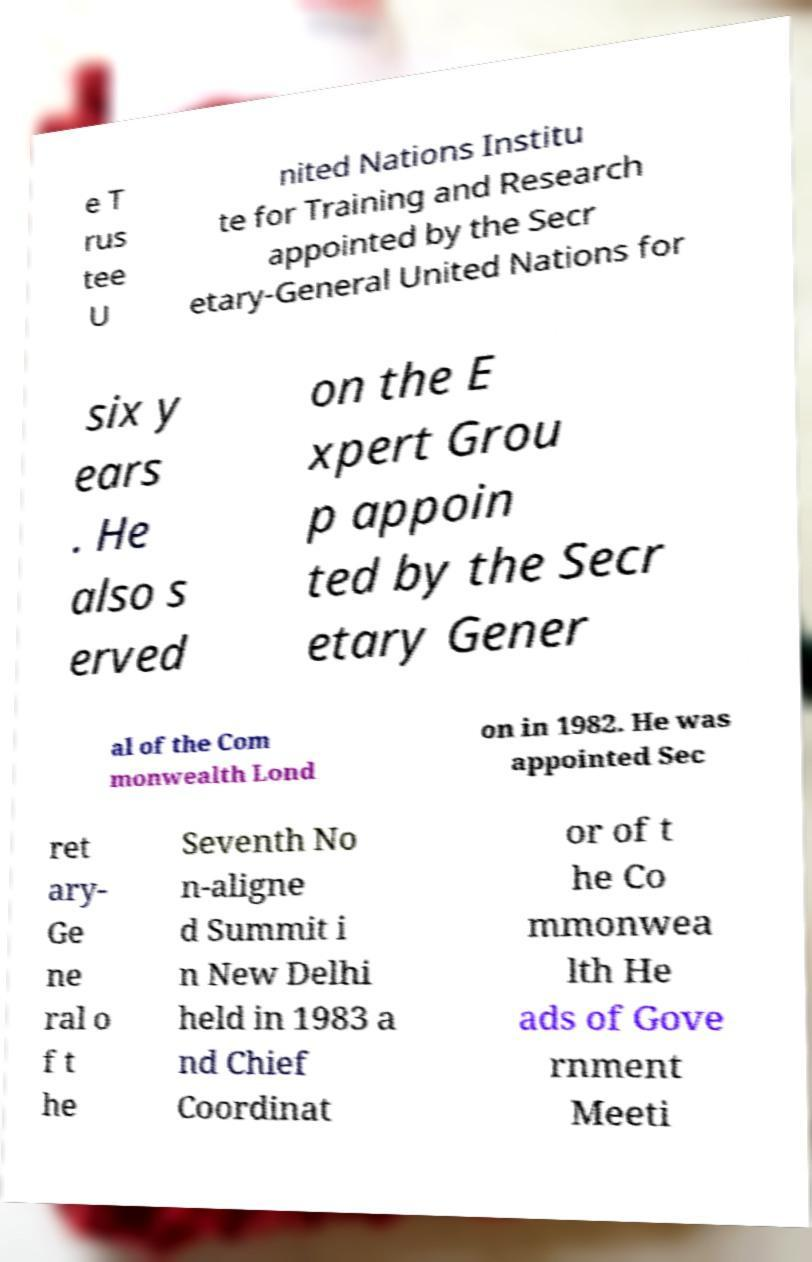I need the written content from this picture converted into text. Can you do that? e T rus tee U nited Nations Institu te for Training and Research appointed by the Secr etary-General United Nations for six y ears . He also s erved on the E xpert Grou p appoin ted by the Secr etary Gener al of the Com monwealth Lond on in 1982. He was appointed Sec ret ary- Ge ne ral o f t he Seventh No n-aligne d Summit i n New Delhi held in 1983 a nd Chief Coordinat or of t he Co mmonwea lth He ads of Gove rnment Meeti 